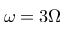Convert formula to latex. <formula><loc_0><loc_0><loc_500><loc_500>\omega = 3 \Omega</formula> 